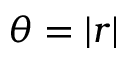Convert formula to latex. <formula><loc_0><loc_0><loc_500><loc_500>\theta = | r |</formula> 